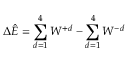Convert formula to latex. <formula><loc_0><loc_0><loc_500><loc_500>\Delta \hat { E } = \sum _ { d = 1 } ^ { 4 } W ^ { + d } - \sum _ { d = 1 } ^ { 4 } W ^ { - d }</formula> 